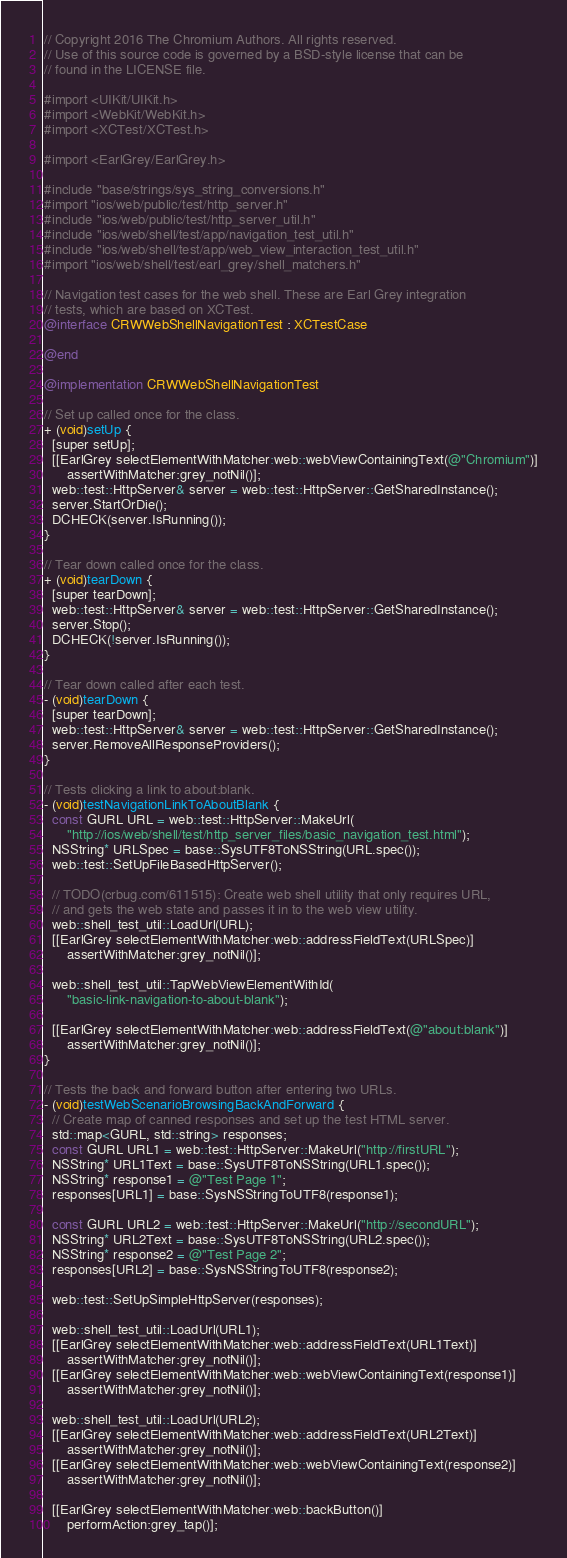<code> <loc_0><loc_0><loc_500><loc_500><_ObjectiveC_>// Copyright 2016 The Chromium Authors. All rights reserved.
// Use of this source code is governed by a BSD-style license that can be
// found in the LICENSE file.

#import <UIKit/UIKit.h>
#import <WebKit/WebKit.h>
#import <XCTest/XCTest.h>

#import <EarlGrey/EarlGrey.h>

#include "base/strings/sys_string_conversions.h"
#import "ios/web/public/test/http_server.h"
#include "ios/web/public/test/http_server_util.h"
#include "ios/web/shell/test/app/navigation_test_util.h"
#include "ios/web/shell/test/app/web_view_interaction_test_util.h"
#import "ios/web/shell/test/earl_grey/shell_matchers.h"

// Navigation test cases for the web shell. These are Earl Grey integration
// tests, which are based on XCTest.
@interface CRWWebShellNavigationTest : XCTestCase

@end

@implementation CRWWebShellNavigationTest

// Set up called once for the class.
+ (void)setUp {
  [super setUp];
  [[EarlGrey selectElementWithMatcher:web::webViewContainingText(@"Chromium")]
      assertWithMatcher:grey_notNil()];
  web::test::HttpServer& server = web::test::HttpServer::GetSharedInstance();
  server.StartOrDie();
  DCHECK(server.IsRunning());
}

// Tear down called once for the class.
+ (void)tearDown {
  [super tearDown];
  web::test::HttpServer& server = web::test::HttpServer::GetSharedInstance();
  server.Stop();
  DCHECK(!server.IsRunning());
}

// Tear down called after each test.
- (void)tearDown {
  [super tearDown];
  web::test::HttpServer& server = web::test::HttpServer::GetSharedInstance();
  server.RemoveAllResponseProviders();
}

// Tests clicking a link to about:blank.
- (void)testNavigationLinkToAboutBlank {
  const GURL URL = web::test::HttpServer::MakeUrl(
      "http://ios/web/shell/test/http_server_files/basic_navigation_test.html");
  NSString* URLSpec = base::SysUTF8ToNSString(URL.spec());
  web::test::SetUpFileBasedHttpServer();

  // TODO(crbug.com/611515): Create web shell utility that only requires URL,
  // and gets the web state and passes it in to the web view utility.
  web::shell_test_util::LoadUrl(URL);
  [[EarlGrey selectElementWithMatcher:web::addressFieldText(URLSpec)]
      assertWithMatcher:grey_notNil()];

  web::shell_test_util::TapWebViewElementWithId(
      "basic-link-navigation-to-about-blank");

  [[EarlGrey selectElementWithMatcher:web::addressFieldText(@"about:blank")]
      assertWithMatcher:grey_notNil()];
}

// Tests the back and forward button after entering two URLs.
- (void)testWebScenarioBrowsingBackAndForward {
  // Create map of canned responses and set up the test HTML server.
  std::map<GURL, std::string> responses;
  const GURL URL1 = web::test::HttpServer::MakeUrl("http://firstURL");
  NSString* URL1Text = base::SysUTF8ToNSString(URL1.spec());
  NSString* response1 = @"Test Page 1";
  responses[URL1] = base::SysNSStringToUTF8(response1);

  const GURL URL2 = web::test::HttpServer::MakeUrl("http://secondURL");
  NSString* URL2Text = base::SysUTF8ToNSString(URL2.spec());
  NSString* response2 = @"Test Page 2";
  responses[URL2] = base::SysNSStringToUTF8(response2);

  web::test::SetUpSimpleHttpServer(responses);

  web::shell_test_util::LoadUrl(URL1);
  [[EarlGrey selectElementWithMatcher:web::addressFieldText(URL1Text)]
      assertWithMatcher:grey_notNil()];
  [[EarlGrey selectElementWithMatcher:web::webViewContainingText(response1)]
      assertWithMatcher:grey_notNil()];

  web::shell_test_util::LoadUrl(URL2);
  [[EarlGrey selectElementWithMatcher:web::addressFieldText(URL2Text)]
      assertWithMatcher:grey_notNil()];
  [[EarlGrey selectElementWithMatcher:web::webViewContainingText(response2)]
      assertWithMatcher:grey_notNil()];

  [[EarlGrey selectElementWithMatcher:web::backButton()]
      performAction:grey_tap()];</code> 